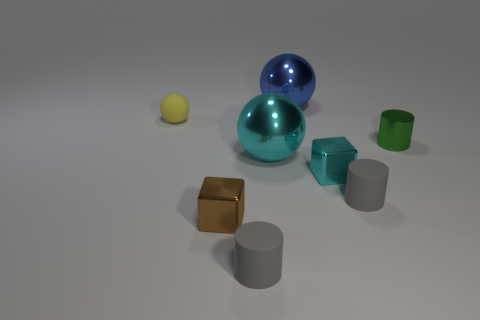Add 1 small rubber cylinders. How many objects exist? 9 Subtract all spheres. How many objects are left? 5 Subtract all small green metallic cylinders. Subtract all small yellow rubber spheres. How many objects are left? 6 Add 2 brown things. How many brown things are left? 3 Add 4 small green shiny objects. How many small green shiny objects exist? 5 Subtract 0 purple spheres. How many objects are left? 8 